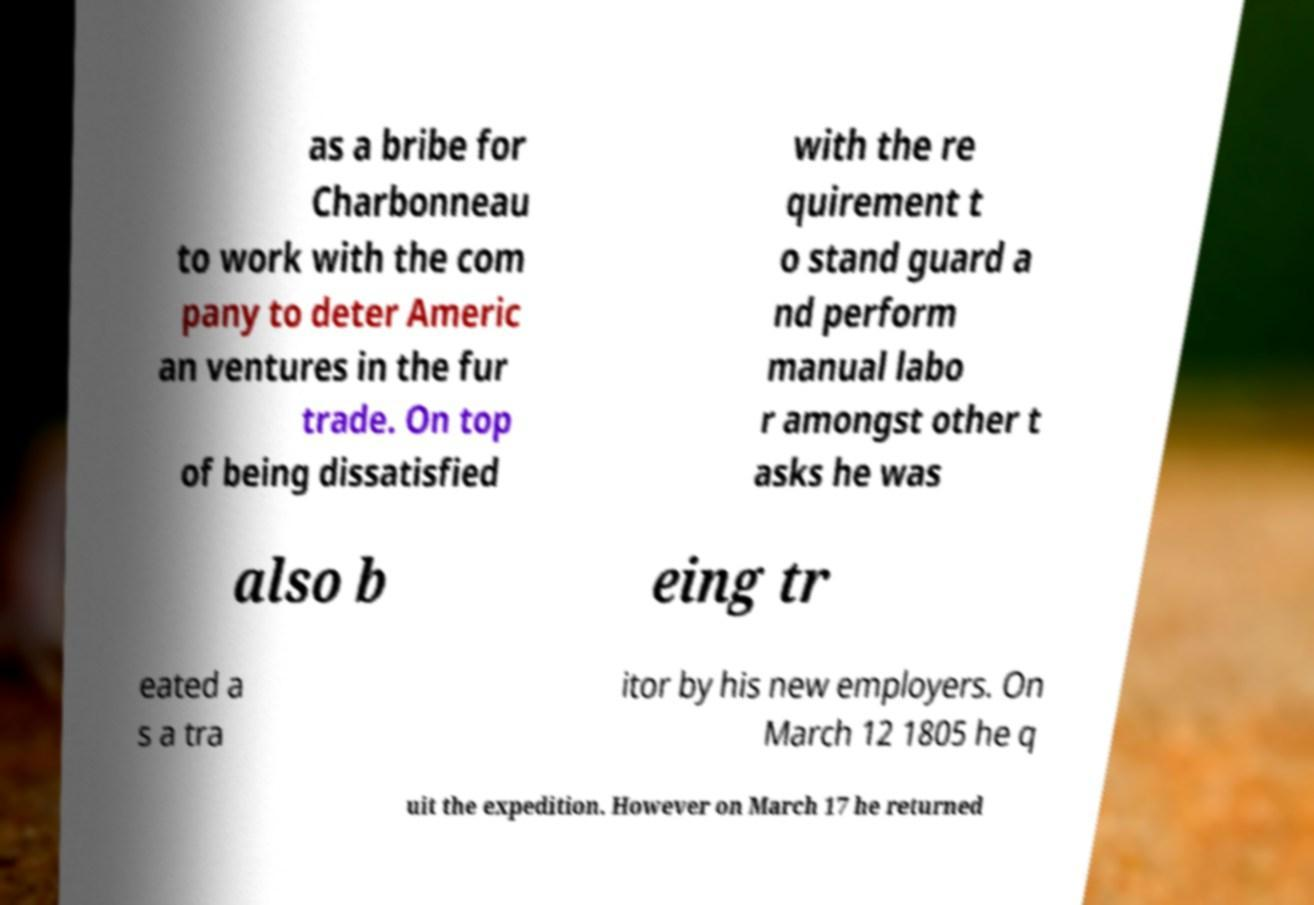For documentation purposes, I need the text within this image transcribed. Could you provide that? as a bribe for Charbonneau to work with the com pany to deter Americ an ventures in the fur trade. On top of being dissatisfied with the re quirement t o stand guard a nd perform manual labo r amongst other t asks he was also b eing tr eated a s a tra itor by his new employers. On March 12 1805 he q uit the expedition. However on March 17 he returned 